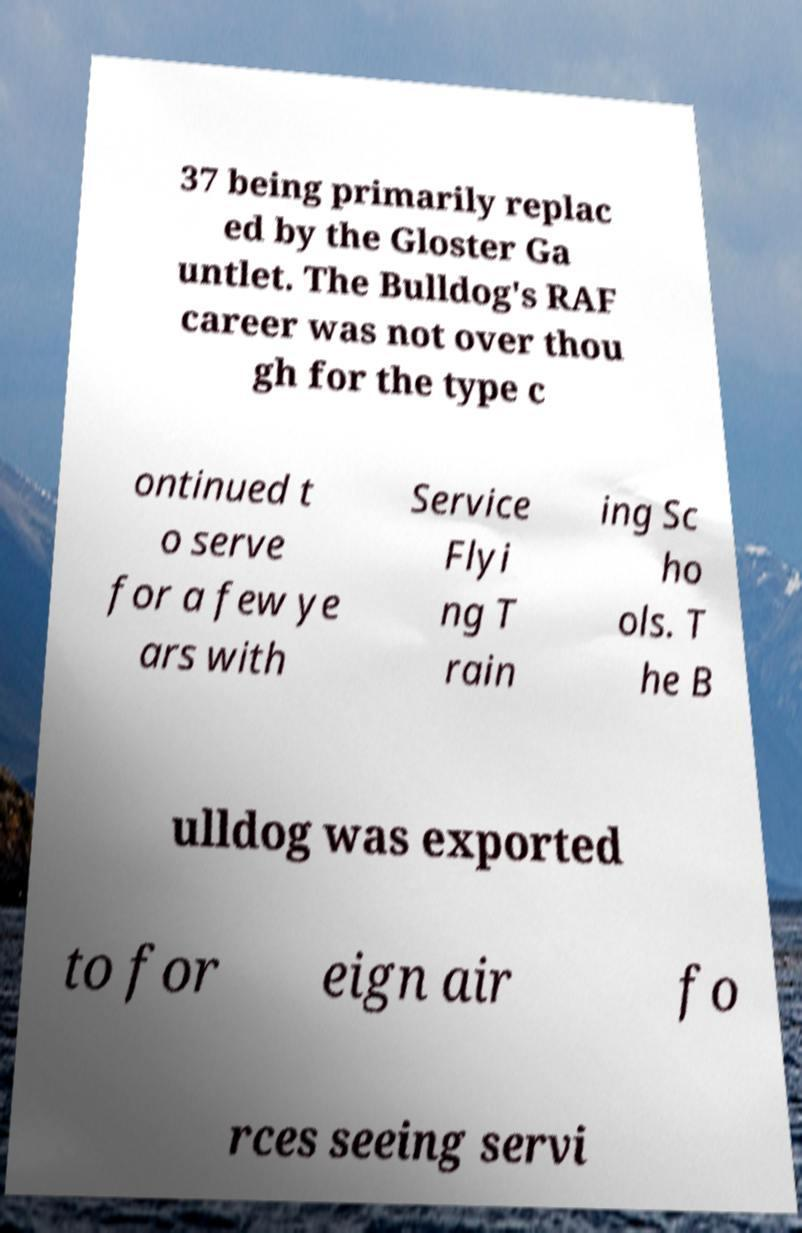Could you extract and type out the text from this image? 37 being primarily replac ed by the Gloster Ga untlet. The Bulldog's RAF career was not over thou gh for the type c ontinued t o serve for a few ye ars with Service Flyi ng T rain ing Sc ho ols. T he B ulldog was exported to for eign air fo rces seeing servi 